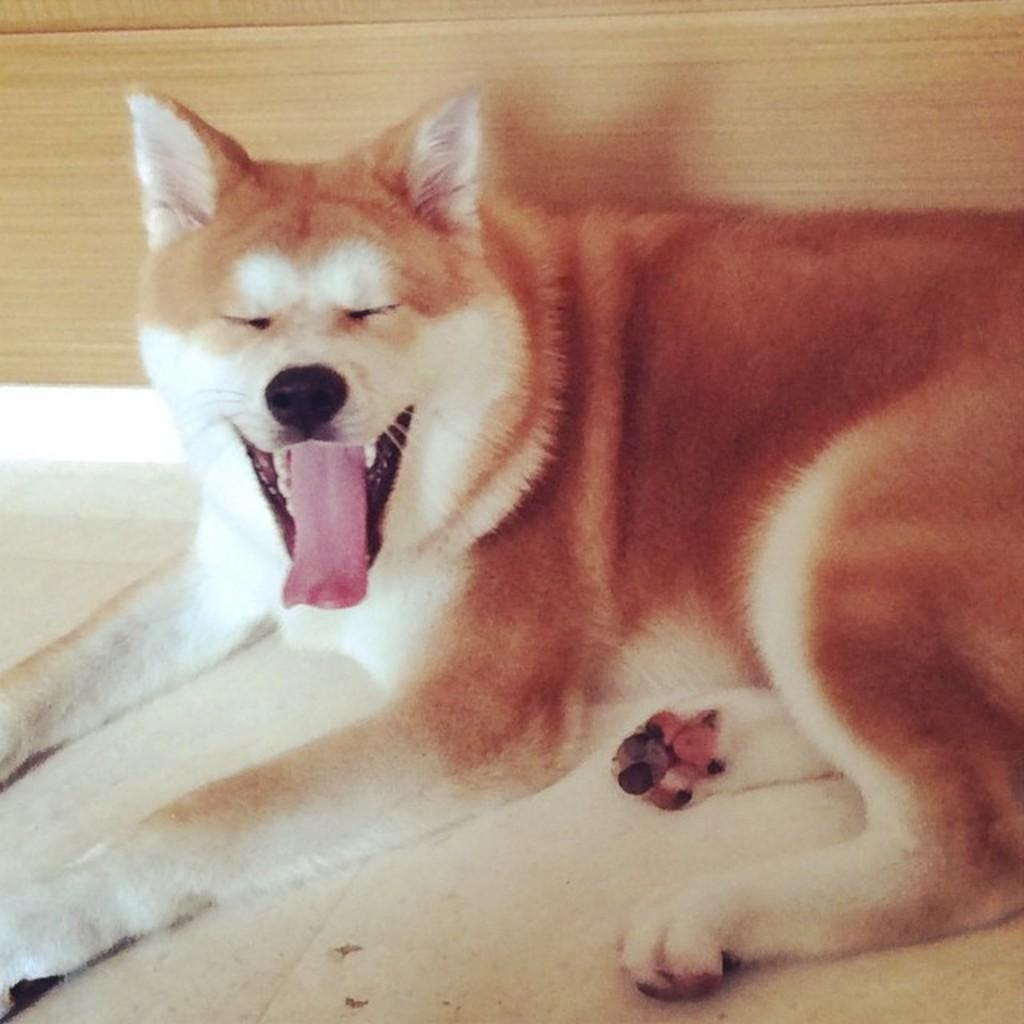What type of animal is in the image? There is a dog in the image. Where is the dog located in the image? The dog is on the floor. What can be seen in the background of the image? There is a wooden wall in the background of the image. What type of stamp is visible on the dog's collar in the image? There is no stamp visible on the dog's collar in the image, as the dog is not wearing a collar. 